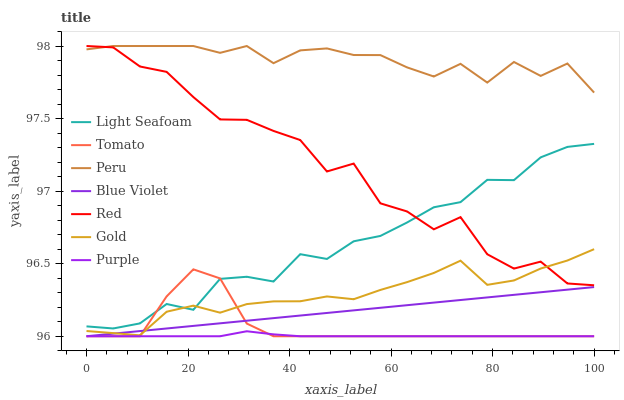Does Purple have the minimum area under the curve?
Answer yes or no. Yes. Does Peru have the maximum area under the curve?
Answer yes or no. Yes. Does Gold have the minimum area under the curve?
Answer yes or no. No. Does Gold have the maximum area under the curve?
Answer yes or no. No. Is Blue Violet the smoothest?
Answer yes or no. Yes. Is Red the roughest?
Answer yes or no. Yes. Is Gold the smoothest?
Answer yes or no. No. Is Gold the roughest?
Answer yes or no. No. Does Tomato have the lowest value?
Answer yes or no. Yes. Does Gold have the lowest value?
Answer yes or no. No. Does Red have the highest value?
Answer yes or no. Yes. Does Gold have the highest value?
Answer yes or no. No. Is Blue Violet less than Light Seafoam?
Answer yes or no. Yes. Is Peru greater than Light Seafoam?
Answer yes or no. Yes. Does Blue Violet intersect Gold?
Answer yes or no. Yes. Is Blue Violet less than Gold?
Answer yes or no. No. Is Blue Violet greater than Gold?
Answer yes or no. No. Does Blue Violet intersect Light Seafoam?
Answer yes or no. No. 